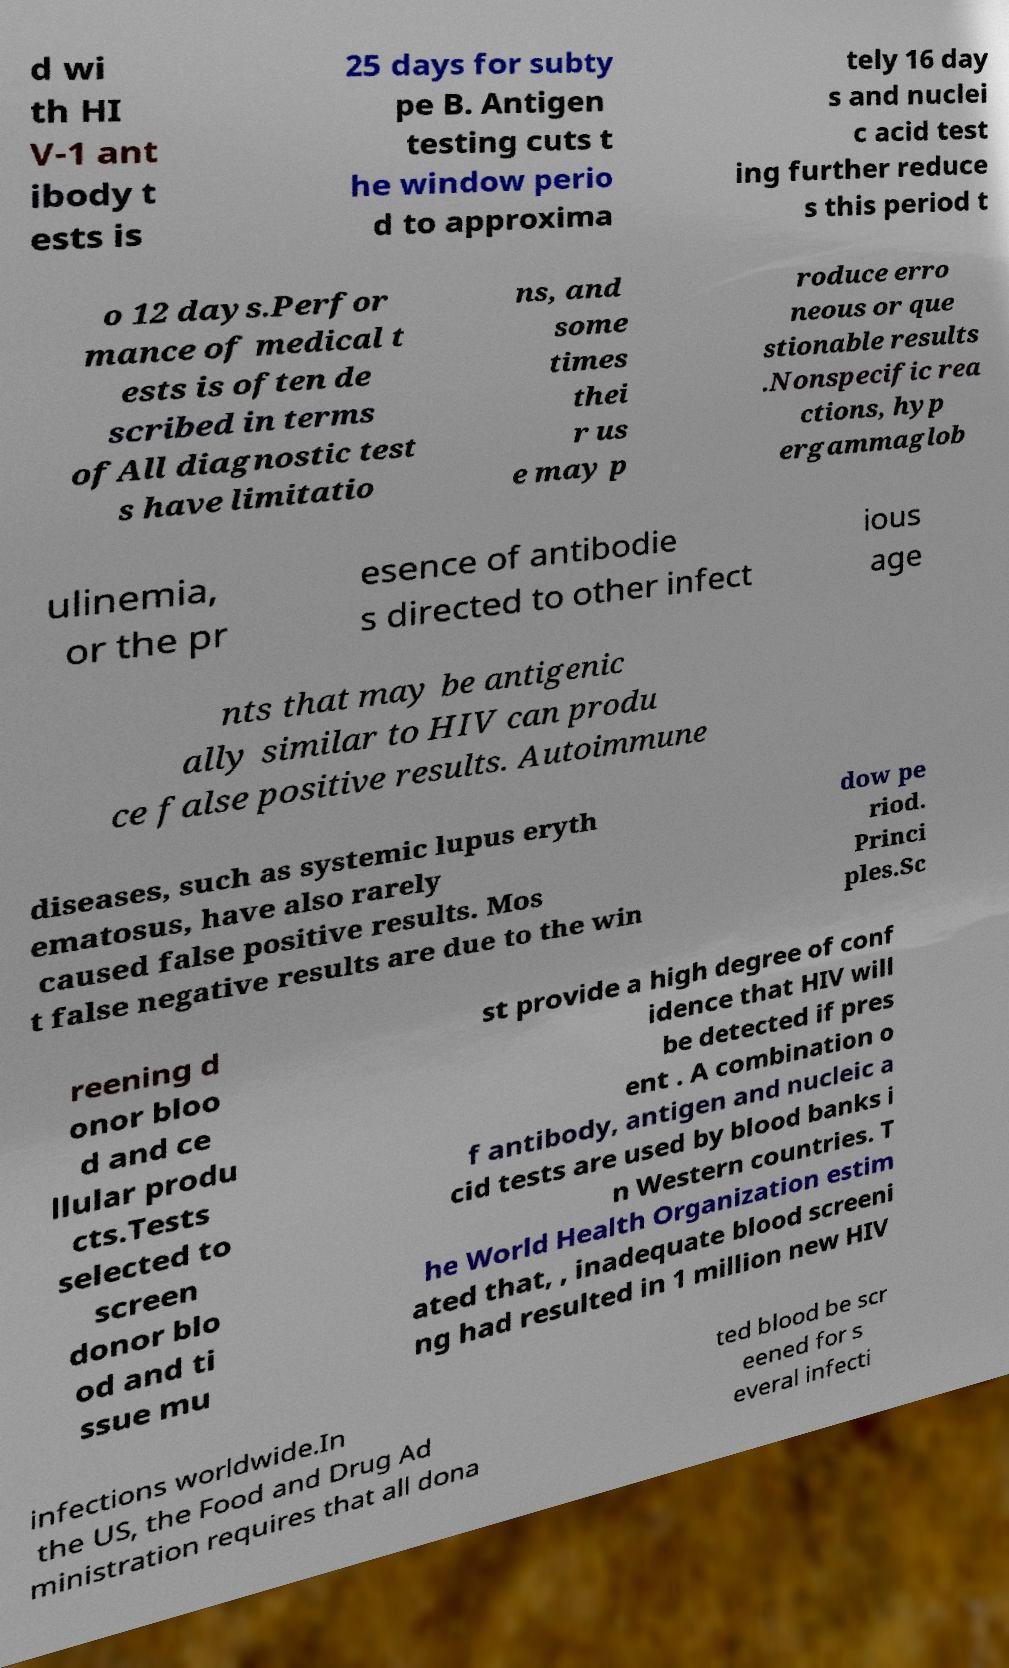Can you accurately transcribe the text from the provided image for me? d wi th HI V-1 ant ibody t ests is 25 days for subty pe B. Antigen testing cuts t he window perio d to approxima tely 16 day s and nuclei c acid test ing further reduce s this period t o 12 days.Perfor mance of medical t ests is often de scribed in terms ofAll diagnostic test s have limitatio ns, and some times thei r us e may p roduce erro neous or que stionable results .Nonspecific rea ctions, hyp ergammaglob ulinemia, or the pr esence of antibodie s directed to other infect ious age nts that may be antigenic ally similar to HIV can produ ce false positive results. Autoimmune diseases, such as systemic lupus eryth ematosus, have also rarely caused false positive results. Mos t false negative results are due to the win dow pe riod. Princi ples.Sc reening d onor bloo d and ce llular produ cts.Tests selected to screen donor blo od and ti ssue mu st provide a high degree of conf idence that HIV will be detected if pres ent . A combination o f antibody, antigen and nucleic a cid tests are used by blood banks i n Western countries. T he World Health Organization estim ated that, , inadequate blood screeni ng had resulted in 1 million new HIV infections worldwide.In the US, the Food and Drug Ad ministration requires that all dona ted blood be scr eened for s everal infecti 